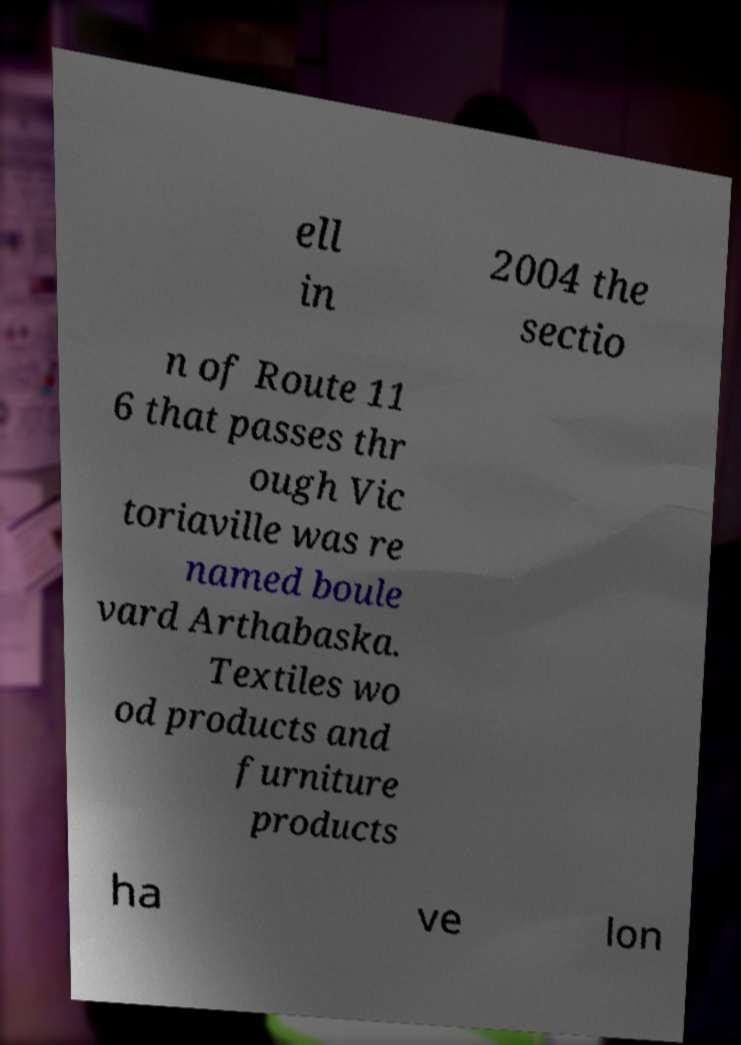For documentation purposes, I need the text within this image transcribed. Could you provide that? ell in 2004 the sectio n of Route 11 6 that passes thr ough Vic toriaville was re named boule vard Arthabaska. Textiles wo od products and furniture products ha ve lon 